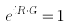Convert formula to latex. <formula><loc_0><loc_0><loc_500><loc_500>e ^ { i R \cdot G } = 1</formula> 